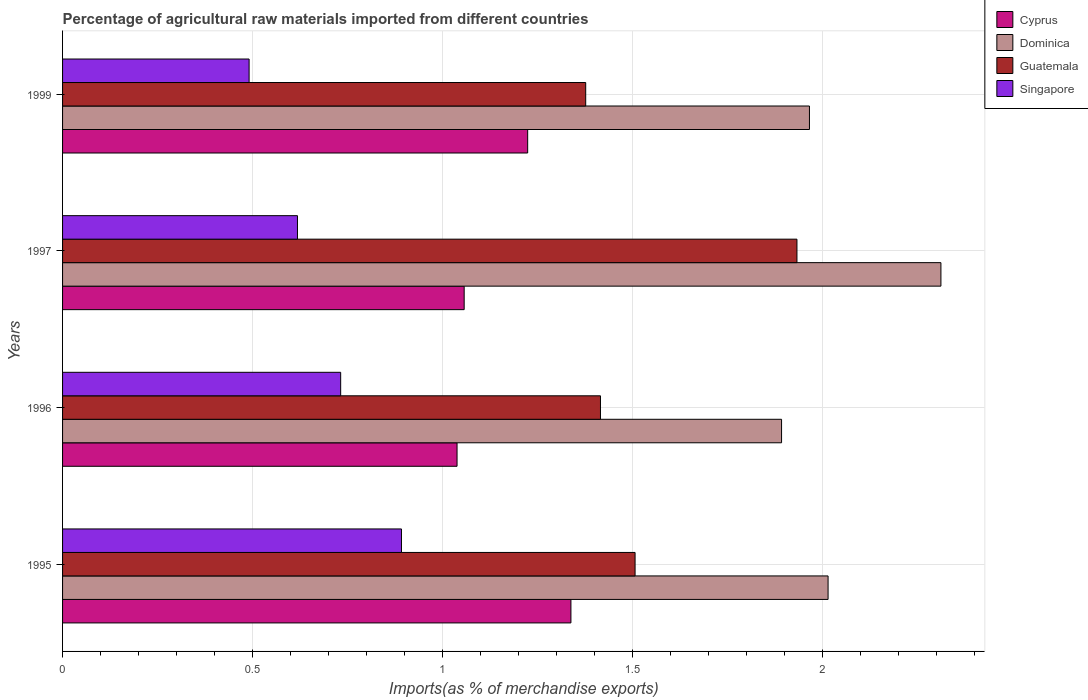Are the number of bars per tick equal to the number of legend labels?
Ensure brevity in your answer.  Yes. Are the number of bars on each tick of the Y-axis equal?
Your answer should be compact. Yes. How many bars are there on the 1st tick from the top?
Ensure brevity in your answer.  4. What is the percentage of imports to different countries in Singapore in 1999?
Make the answer very short. 0.49. Across all years, what is the maximum percentage of imports to different countries in Guatemala?
Ensure brevity in your answer.  1.93. Across all years, what is the minimum percentage of imports to different countries in Singapore?
Your response must be concise. 0.49. In which year was the percentage of imports to different countries in Singapore maximum?
Your answer should be compact. 1995. What is the total percentage of imports to different countries in Cyprus in the graph?
Your answer should be compact. 4.66. What is the difference between the percentage of imports to different countries in Guatemala in 1996 and that in 1999?
Ensure brevity in your answer.  0.04. What is the difference between the percentage of imports to different countries in Dominica in 1997 and the percentage of imports to different countries in Singapore in 1999?
Ensure brevity in your answer.  1.82. What is the average percentage of imports to different countries in Cyprus per year?
Your answer should be compact. 1.16. In the year 1999, what is the difference between the percentage of imports to different countries in Guatemala and percentage of imports to different countries in Singapore?
Your answer should be compact. 0.89. What is the ratio of the percentage of imports to different countries in Dominica in 1996 to that in 1999?
Provide a succinct answer. 0.96. Is the percentage of imports to different countries in Cyprus in 1995 less than that in 1997?
Make the answer very short. No. What is the difference between the highest and the second highest percentage of imports to different countries in Guatemala?
Keep it short and to the point. 0.43. What is the difference between the highest and the lowest percentage of imports to different countries in Singapore?
Give a very brief answer. 0.4. In how many years, is the percentage of imports to different countries in Cyprus greater than the average percentage of imports to different countries in Cyprus taken over all years?
Your answer should be very brief. 2. Is the sum of the percentage of imports to different countries in Singapore in 1995 and 1997 greater than the maximum percentage of imports to different countries in Guatemala across all years?
Keep it short and to the point. No. What does the 4th bar from the top in 1999 represents?
Offer a terse response. Cyprus. What does the 1st bar from the bottom in 1995 represents?
Offer a very short reply. Cyprus. Is it the case that in every year, the sum of the percentage of imports to different countries in Dominica and percentage of imports to different countries in Singapore is greater than the percentage of imports to different countries in Guatemala?
Give a very brief answer. Yes. How many bars are there?
Provide a succinct answer. 16. What is the difference between two consecutive major ticks on the X-axis?
Keep it short and to the point. 0.5. Are the values on the major ticks of X-axis written in scientific E-notation?
Your response must be concise. No. Does the graph contain any zero values?
Your answer should be very brief. No. How many legend labels are there?
Offer a terse response. 4. What is the title of the graph?
Ensure brevity in your answer.  Percentage of agricultural raw materials imported from different countries. What is the label or title of the X-axis?
Your response must be concise. Imports(as % of merchandise exports). What is the Imports(as % of merchandise exports) in Cyprus in 1995?
Your answer should be very brief. 1.34. What is the Imports(as % of merchandise exports) in Dominica in 1995?
Provide a short and direct response. 2.02. What is the Imports(as % of merchandise exports) in Guatemala in 1995?
Keep it short and to the point. 1.51. What is the Imports(as % of merchandise exports) of Singapore in 1995?
Your response must be concise. 0.89. What is the Imports(as % of merchandise exports) of Cyprus in 1996?
Make the answer very short. 1.04. What is the Imports(as % of merchandise exports) in Dominica in 1996?
Your response must be concise. 1.89. What is the Imports(as % of merchandise exports) of Guatemala in 1996?
Give a very brief answer. 1.42. What is the Imports(as % of merchandise exports) of Singapore in 1996?
Provide a succinct answer. 0.73. What is the Imports(as % of merchandise exports) in Cyprus in 1997?
Ensure brevity in your answer.  1.06. What is the Imports(as % of merchandise exports) of Dominica in 1997?
Make the answer very short. 2.31. What is the Imports(as % of merchandise exports) of Guatemala in 1997?
Your response must be concise. 1.93. What is the Imports(as % of merchandise exports) of Singapore in 1997?
Your answer should be compact. 0.62. What is the Imports(as % of merchandise exports) in Cyprus in 1999?
Your answer should be very brief. 1.22. What is the Imports(as % of merchandise exports) of Dominica in 1999?
Your answer should be compact. 1.97. What is the Imports(as % of merchandise exports) of Guatemala in 1999?
Offer a terse response. 1.38. What is the Imports(as % of merchandise exports) in Singapore in 1999?
Ensure brevity in your answer.  0.49. Across all years, what is the maximum Imports(as % of merchandise exports) in Cyprus?
Your answer should be compact. 1.34. Across all years, what is the maximum Imports(as % of merchandise exports) in Dominica?
Give a very brief answer. 2.31. Across all years, what is the maximum Imports(as % of merchandise exports) in Guatemala?
Give a very brief answer. 1.93. Across all years, what is the maximum Imports(as % of merchandise exports) in Singapore?
Offer a terse response. 0.89. Across all years, what is the minimum Imports(as % of merchandise exports) of Cyprus?
Your response must be concise. 1.04. Across all years, what is the minimum Imports(as % of merchandise exports) of Dominica?
Ensure brevity in your answer.  1.89. Across all years, what is the minimum Imports(as % of merchandise exports) in Guatemala?
Your response must be concise. 1.38. Across all years, what is the minimum Imports(as % of merchandise exports) of Singapore?
Keep it short and to the point. 0.49. What is the total Imports(as % of merchandise exports) of Cyprus in the graph?
Provide a short and direct response. 4.66. What is the total Imports(as % of merchandise exports) of Dominica in the graph?
Your response must be concise. 8.19. What is the total Imports(as % of merchandise exports) of Guatemala in the graph?
Your answer should be compact. 6.23. What is the total Imports(as % of merchandise exports) of Singapore in the graph?
Offer a terse response. 2.73. What is the difference between the Imports(as % of merchandise exports) in Cyprus in 1995 and that in 1996?
Provide a short and direct response. 0.3. What is the difference between the Imports(as % of merchandise exports) of Dominica in 1995 and that in 1996?
Provide a succinct answer. 0.12. What is the difference between the Imports(as % of merchandise exports) of Guatemala in 1995 and that in 1996?
Offer a terse response. 0.09. What is the difference between the Imports(as % of merchandise exports) of Singapore in 1995 and that in 1996?
Your answer should be very brief. 0.16. What is the difference between the Imports(as % of merchandise exports) of Cyprus in 1995 and that in 1997?
Provide a succinct answer. 0.28. What is the difference between the Imports(as % of merchandise exports) in Dominica in 1995 and that in 1997?
Offer a very short reply. -0.3. What is the difference between the Imports(as % of merchandise exports) of Guatemala in 1995 and that in 1997?
Provide a succinct answer. -0.43. What is the difference between the Imports(as % of merchandise exports) in Singapore in 1995 and that in 1997?
Give a very brief answer. 0.27. What is the difference between the Imports(as % of merchandise exports) in Cyprus in 1995 and that in 1999?
Provide a succinct answer. 0.11. What is the difference between the Imports(as % of merchandise exports) in Dominica in 1995 and that in 1999?
Give a very brief answer. 0.05. What is the difference between the Imports(as % of merchandise exports) in Guatemala in 1995 and that in 1999?
Your response must be concise. 0.13. What is the difference between the Imports(as % of merchandise exports) in Singapore in 1995 and that in 1999?
Offer a very short reply. 0.4. What is the difference between the Imports(as % of merchandise exports) of Cyprus in 1996 and that in 1997?
Your answer should be very brief. -0.02. What is the difference between the Imports(as % of merchandise exports) of Dominica in 1996 and that in 1997?
Keep it short and to the point. -0.42. What is the difference between the Imports(as % of merchandise exports) in Guatemala in 1996 and that in 1997?
Give a very brief answer. -0.52. What is the difference between the Imports(as % of merchandise exports) in Singapore in 1996 and that in 1997?
Your response must be concise. 0.11. What is the difference between the Imports(as % of merchandise exports) in Cyprus in 1996 and that in 1999?
Provide a succinct answer. -0.19. What is the difference between the Imports(as % of merchandise exports) in Dominica in 1996 and that in 1999?
Make the answer very short. -0.07. What is the difference between the Imports(as % of merchandise exports) in Guatemala in 1996 and that in 1999?
Your response must be concise. 0.04. What is the difference between the Imports(as % of merchandise exports) of Singapore in 1996 and that in 1999?
Your answer should be very brief. 0.24. What is the difference between the Imports(as % of merchandise exports) of Cyprus in 1997 and that in 1999?
Provide a succinct answer. -0.17. What is the difference between the Imports(as % of merchandise exports) in Dominica in 1997 and that in 1999?
Give a very brief answer. 0.35. What is the difference between the Imports(as % of merchandise exports) of Guatemala in 1997 and that in 1999?
Your response must be concise. 0.56. What is the difference between the Imports(as % of merchandise exports) in Singapore in 1997 and that in 1999?
Your response must be concise. 0.13. What is the difference between the Imports(as % of merchandise exports) of Cyprus in 1995 and the Imports(as % of merchandise exports) of Dominica in 1996?
Offer a very short reply. -0.55. What is the difference between the Imports(as % of merchandise exports) in Cyprus in 1995 and the Imports(as % of merchandise exports) in Guatemala in 1996?
Give a very brief answer. -0.08. What is the difference between the Imports(as % of merchandise exports) of Cyprus in 1995 and the Imports(as % of merchandise exports) of Singapore in 1996?
Give a very brief answer. 0.61. What is the difference between the Imports(as % of merchandise exports) in Dominica in 1995 and the Imports(as % of merchandise exports) in Guatemala in 1996?
Give a very brief answer. 0.6. What is the difference between the Imports(as % of merchandise exports) of Dominica in 1995 and the Imports(as % of merchandise exports) of Singapore in 1996?
Your answer should be very brief. 1.28. What is the difference between the Imports(as % of merchandise exports) in Guatemala in 1995 and the Imports(as % of merchandise exports) in Singapore in 1996?
Make the answer very short. 0.78. What is the difference between the Imports(as % of merchandise exports) in Cyprus in 1995 and the Imports(as % of merchandise exports) in Dominica in 1997?
Your answer should be very brief. -0.97. What is the difference between the Imports(as % of merchandise exports) of Cyprus in 1995 and the Imports(as % of merchandise exports) of Guatemala in 1997?
Your answer should be compact. -0.6. What is the difference between the Imports(as % of merchandise exports) in Cyprus in 1995 and the Imports(as % of merchandise exports) in Singapore in 1997?
Provide a succinct answer. 0.72. What is the difference between the Imports(as % of merchandise exports) of Dominica in 1995 and the Imports(as % of merchandise exports) of Guatemala in 1997?
Provide a short and direct response. 0.08. What is the difference between the Imports(as % of merchandise exports) in Dominica in 1995 and the Imports(as % of merchandise exports) in Singapore in 1997?
Ensure brevity in your answer.  1.4. What is the difference between the Imports(as % of merchandise exports) in Cyprus in 1995 and the Imports(as % of merchandise exports) in Dominica in 1999?
Your answer should be very brief. -0.63. What is the difference between the Imports(as % of merchandise exports) of Cyprus in 1995 and the Imports(as % of merchandise exports) of Guatemala in 1999?
Your answer should be very brief. -0.04. What is the difference between the Imports(as % of merchandise exports) in Cyprus in 1995 and the Imports(as % of merchandise exports) in Singapore in 1999?
Keep it short and to the point. 0.85. What is the difference between the Imports(as % of merchandise exports) in Dominica in 1995 and the Imports(as % of merchandise exports) in Guatemala in 1999?
Provide a succinct answer. 0.64. What is the difference between the Imports(as % of merchandise exports) in Dominica in 1995 and the Imports(as % of merchandise exports) in Singapore in 1999?
Offer a very short reply. 1.52. What is the difference between the Imports(as % of merchandise exports) in Guatemala in 1995 and the Imports(as % of merchandise exports) in Singapore in 1999?
Ensure brevity in your answer.  1.02. What is the difference between the Imports(as % of merchandise exports) of Cyprus in 1996 and the Imports(as % of merchandise exports) of Dominica in 1997?
Provide a succinct answer. -1.27. What is the difference between the Imports(as % of merchandise exports) of Cyprus in 1996 and the Imports(as % of merchandise exports) of Guatemala in 1997?
Ensure brevity in your answer.  -0.9. What is the difference between the Imports(as % of merchandise exports) of Cyprus in 1996 and the Imports(as % of merchandise exports) of Singapore in 1997?
Your response must be concise. 0.42. What is the difference between the Imports(as % of merchandise exports) of Dominica in 1996 and the Imports(as % of merchandise exports) of Guatemala in 1997?
Provide a succinct answer. -0.04. What is the difference between the Imports(as % of merchandise exports) in Dominica in 1996 and the Imports(as % of merchandise exports) in Singapore in 1997?
Make the answer very short. 1.27. What is the difference between the Imports(as % of merchandise exports) of Guatemala in 1996 and the Imports(as % of merchandise exports) of Singapore in 1997?
Provide a succinct answer. 0.8. What is the difference between the Imports(as % of merchandise exports) of Cyprus in 1996 and the Imports(as % of merchandise exports) of Dominica in 1999?
Your answer should be very brief. -0.93. What is the difference between the Imports(as % of merchandise exports) in Cyprus in 1996 and the Imports(as % of merchandise exports) in Guatemala in 1999?
Provide a short and direct response. -0.34. What is the difference between the Imports(as % of merchandise exports) of Cyprus in 1996 and the Imports(as % of merchandise exports) of Singapore in 1999?
Provide a succinct answer. 0.55. What is the difference between the Imports(as % of merchandise exports) in Dominica in 1996 and the Imports(as % of merchandise exports) in Guatemala in 1999?
Make the answer very short. 0.52. What is the difference between the Imports(as % of merchandise exports) of Dominica in 1996 and the Imports(as % of merchandise exports) of Singapore in 1999?
Keep it short and to the point. 1.4. What is the difference between the Imports(as % of merchandise exports) of Guatemala in 1996 and the Imports(as % of merchandise exports) of Singapore in 1999?
Offer a terse response. 0.93. What is the difference between the Imports(as % of merchandise exports) in Cyprus in 1997 and the Imports(as % of merchandise exports) in Dominica in 1999?
Make the answer very short. -0.91. What is the difference between the Imports(as % of merchandise exports) in Cyprus in 1997 and the Imports(as % of merchandise exports) in Guatemala in 1999?
Your answer should be very brief. -0.32. What is the difference between the Imports(as % of merchandise exports) of Cyprus in 1997 and the Imports(as % of merchandise exports) of Singapore in 1999?
Your answer should be compact. 0.57. What is the difference between the Imports(as % of merchandise exports) of Dominica in 1997 and the Imports(as % of merchandise exports) of Guatemala in 1999?
Provide a succinct answer. 0.94. What is the difference between the Imports(as % of merchandise exports) in Dominica in 1997 and the Imports(as % of merchandise exports) in Singapore in 1999?
Your answer should be compact. 1.82. What is the difference between the Imports(as % of merchandise exports) of Guatemala in 1997 and the Imports(as % of merchandise exports) of Singapore in 1999?
Provide a short and direct response. 1.44. What is the average Imports(as % of merchandise exports) in Cyprus per year?
Offer a very short reply. 1.16. What is the average Imports(as % of merchandise exports) of Dominica per year?
Provide a succinct answer. 2.05. What is the average Imports(as % of merchandise exports) in Guatemala per year?
Keep it short and to the point. 1.56. What is the average Imports(as % of merchandise exports) of Singapore per year?
Give a very brief answer. 0.68. In the year 1995, what is the difference between the Imports(as % of merchandise exports) in Cyprus and Imports(as % of merchandise exports) in Dominica?
Give a very brief answer. -0.68. In the year 1995, what is the difference between the Imports(as % of merchandise exports) of Cyprus and Imports(as % of merchandise exports) of Guatemala?
Ensure brevity in your answer.  -0.17. In the year 1995, what is the difference between the Imports(as % of merchandise exports) of Cyprus and Imports(as % of merchandise exports) of Singapore?
Offer a very short reply. 0.45. In the year 1995, what is the difference between the Imports(as % of merchandise exports) of Dominica and Imports(as % of merchandise exports) of Guatemala?
Make the answer very short. 0.51. In the year 1995, what is the difference between the Imports(as % of merchandise exports) of Dominica and Imports(as % of merchandise exports) of Singapore?
Offer a very short reply. 1.12. In the year 1995, what is the difference between the Imports(as % of merchandise exports) of Guatemala and Imports(as % of merchandise exports) of Singapore?
Your response must be concise. 0.62. In the year 1996, what is the difference between the Imports(as % of merchandise exports) in Cyprus and Imports(as % of merchandise exports) in Dominica?
Provide a short and direct response. -0.85. In the year 1996, what is the difference between the Imports(as % of merchandise exports) in Cyprus and Imports(as % of merchandise exports) in Guatemala?
Your answer should be very brief. -0.38. In the year 1996, what is the difference between the Imports(as % of merchandise exports) in Cyprus and Imports(as % of merchandise exports) in Singapore?
Offer a very short reply. 0.31. In the year 1996, what is the difference between the Imports(as % of merchandise exports) in Dominica and Imports(as % of merchandise exports) in Guatemala?
Keep it short and to the point. 0.48. In the year 1996, what is the difference between the Imports(as % of merchandise exports) in Dominica and Imports(as % of merchandise exports) in Singapore?
Make the answer very short. 1.16. In the year 1996, what is the difference between the Imports(as % of merchandise exports) of Guatemala and Imports(as % of merchandise exports) of Singapore?
Offer a very short reply. 0.68. In the year 1997, what is the difference between the Imports(as % of merchandise exports) in Cyprus and Imports(as % of merchandise exports) in Dominica?
Your answer should be very brief. -1.26. In the year 1997, what is the difference between the Imports(as % of merchandise exports) in Cyprus and Imports(as % of merchandise exports) in Guatemala?
Provide a short and direct response. -0.88. In the year 1997, what is the difference between the Imports(as % of merchandise exports) in Cyprus and Imports(as % of merchandise exports) in Singapore?
Make the answer very short. 0.44. In the year 1997, what is the difference between the Imports(as % of merchandise exports) in Dominica and Imports(as % of merchandise exports) in Guatemala?
Your answer should be very brief. 0.38. In the year 1997, what is the difference between the Imports(as % of merchandise exports) of Dominica and Imports(as % of merchandise exports) of Singapore?
Provide a short and direct response. 1.69. In the year 1997, what is the difference between the Imports(as % of merchandise exports) of Guatemala and Imports(as % of merchandise exports) of Singapore?
Your answer should be compact. 1.32. In the year 1999, what is the difference between the Imports(as % of merchandise exports) in Cyprus and Imports(as % of merchandise exports) in Dominica?
Offer a very short reply. -0.74. In the year 1999, what is the difference between the Imports(as % of merchandise exports) in Cyprus and Imports(as % of merchandise exports) in Guatemala?
Keep it short and to the point. -0.15. In the year 1999, what is the difference between the Imports(as % of merchandise exports) in Cyprus and Imports(as % of merchandise exports) in Singapore?
Keep it short and to the point. 0.73. In the year 1999, what is the difference between the Imports(as % of merchandise exports) of Dominica and Imports(as % of merchandise exports) of Guatemala?
Keep it short and to the point. 0.59. In the year 1999, what is the difference between the Imports(as % of merchandise exports) of Dominica and Imports(as % of merchandise exports) of Singapore?
Make the answer very short. 1.48. In the year 1999, what is the difference between the Imports(as % of merchandise exports) in Guatemala and Imports(as % of merchandise exports) in Singapore?
Ensure brevity in your answer.  0.89. What is the ratio of the Imports(as % of merchandise exports) of Cyprus in 1995 to that in 1996?
Provide a succinct answer. 1.29. What is the ratio of the Imports(as % of merchandise exports) of Dominica in 1995 to that in 1996?
Offer a very short reply. 1.06. What is the ratio of the Imports(as % of merchandise exports) in Guatemala in 1995 to that in 1996?
Give a very brief answer. 1.06. What is the ratio of the Imports(as % of merchandise exports) in Singapore in 1995 to that in 1996?
Your answer should be very brief. 1.22. What is the ratio of the Imports(as % of merchandise exports) of Cyprus in 1995 to that in 1997?
Your response must be concise. 1.27. What is the ratio of the Imports(as % of merchandise exports) in Dominica in 1995 to that in 1997?
Give a very brief answer. 0.87. What is the ratio of the Imports(as % of merchandise exports) of Guatemala in 1995 to that in 1997?
Your response must be concise. 0.78. What is the ratio of the Imports(as % of merchandise exports) in Singapore in 1995 to that in 1997?
Your answer should be compact. 1.44. What is the ratio of the Imports(as % of merchandise exports) in Cyprus in 1995 to that in 1999?
Provide a succinct answer. 1.09. What is the ratio of the Imports(as % of merchandise exports) in Dominica in 1995 to that in 1999?
Your answer should be very brief. 1.02. What is the ratio of the Imports(as % of merchandise exports) of Guatemala in 1995 to that in 1999?
Your response must be concise. 1.09. What is the ratio of the Imports(as % of merchandise exports) of Singapore in 1995 to that in 1999?
Give a very brief answer. 1.82. What is the ratio of the Imports(as % of merchandise exports) in Cyprus in 1996 to that in 1997?
Offer a terse response. 0.98. What is the ratio of the Imports(as % of merchandise exports) of Dominica in 1996 to that in 1997?
Offer a terse response. 0.82. What is the ratio of the Imports(as % of merchandise exports) in Guatemala in 1996 to that in 1997?
Offer a very short reply. 0.73. What is the ratio of the Imports(as % of merchandise exports) of Singapore in 1996 to that in 1997?
Give a very brief answer. 1.18. What is the ratio of the Imports(as % of merchandise exports) of Cyprus in 1996 to that in 1999?
Provide a succinct answer. 0.85. What is the ratio of the Imports(as % of merchandise exports) in Dominica in 1996 to that in 1999?
Your answer should be very brief. 0.96. What is the ratio of the Imports(as % of merchandise exports) in Guatemala in 1996 to that in 1999?
Give a very brief answer. 1.03. What is the ratio of the Imports(as % of merchandise exports) of Singapore in 1996 to that in 1999?
Give a very brief answer. 1.49. What is the ratio of the Imports(as % of merchandise exports) in Cyprus in 1997 to that in 1999?
Your answer should be compact. 0.86. What is the ratio of the Imports(as % of merchandise exports) of Dominica in 1997 to that in 1999?
Keep it short and to the point. 1.18. What is the ratio of the Imports(as % of merchandise exports) of Guatemala in 1997 to that in 1999?
Keep it short and to the point. 1.4. What is the ratio of the Imports(as % of merchandise exports) in Singapore in 1997 to that in 1999?
Offer a terse response. 1.26. What is the difference between the highest and the second highest Imports(as % of merchandise exports) of Cyprus?
Offer a terse response. 0.11. What is the difference between the highest and the second highest Imports(as % of merchandise exports) of Dominica?
Provide a succinct answer. 0.3. What is the difference between the highest and the second highest Imports(as % of merchandise exports) of Guatemala?
Make the answer very short. 0.43. What is the difference between the highest and the second highest Imports(as % of merchandise exports) in Singapore?
Offer a terse response. 0.16. What is the difference between the highest and the lowest Imports(as % of merchandise exports) in Cyprus?
Provide a short and direct response. 0.3. What is the difference between the highest and the lowest Imports(as % of merchandise exports) of Dominica?
Provide a short and direct response. 0.42. What is the difference between the highest and the lowest Imports(as % of merchandise exports) in Guatemala?
Ensure brevity in your answer.  0.56. What is the difference between the highest and the lowest Imports(as % of merchandise exports) in Singapore?
Make the answer very short. 0.4. 